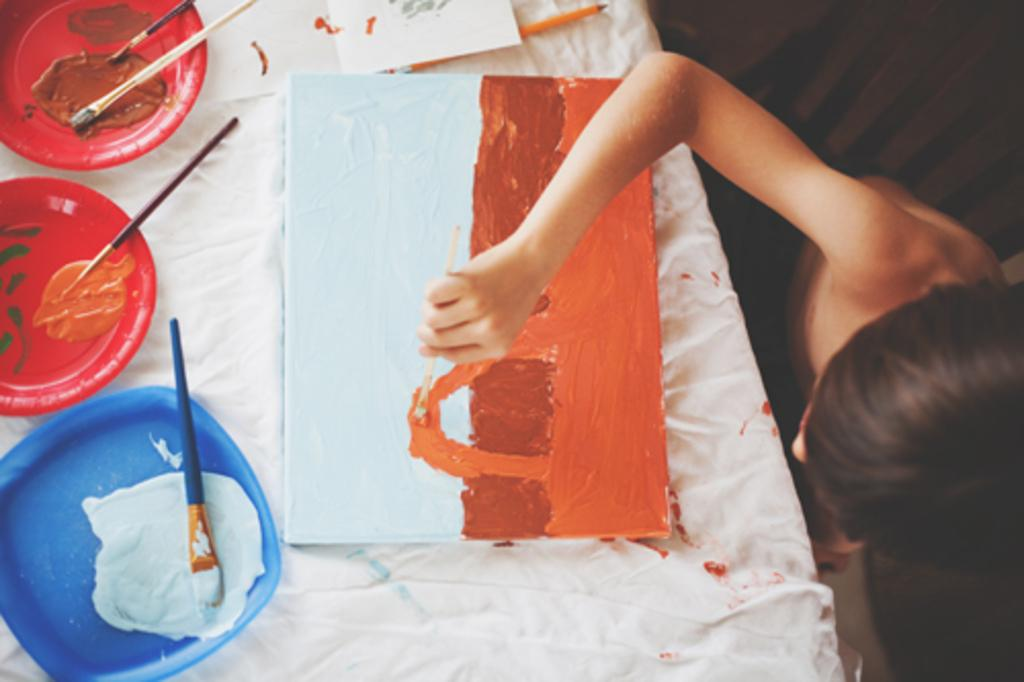What is the main subject of the picture? The main subject of the picture is a kid. What is the kid doing in the picture? The kid is painting a picture. What is the kid using to paint? The kid is using brushes to paint. What can be seen on the board in the picture? There are different colors on the board in the picture. What type of division is being performed by the cub in the picture? There is no cub or division present in the picture; it features a kid painting a picture. 